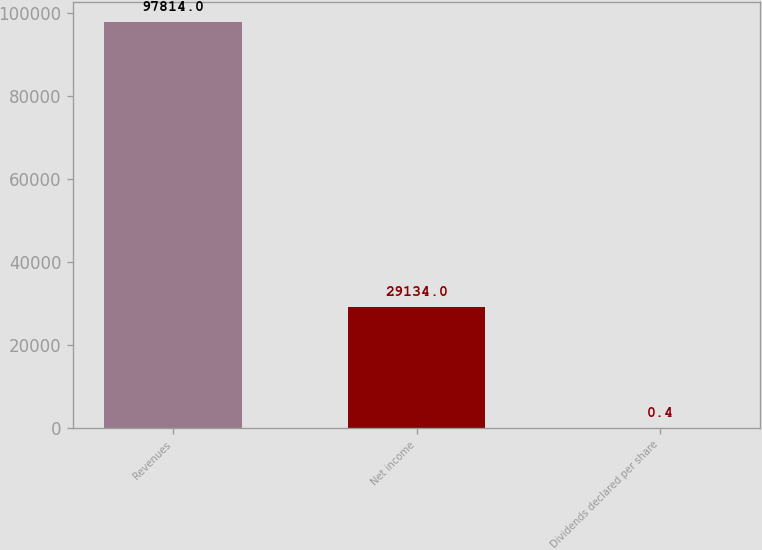Convert chart. <chart><loc_0><loc_0><loc_500><loc_500><bar_chart><fcel>Revenues<fcel>Net income<fcel>Dividends declared per share<nl><fcel>97814<fcel>29134<fcel>0.4<nl></chart> 